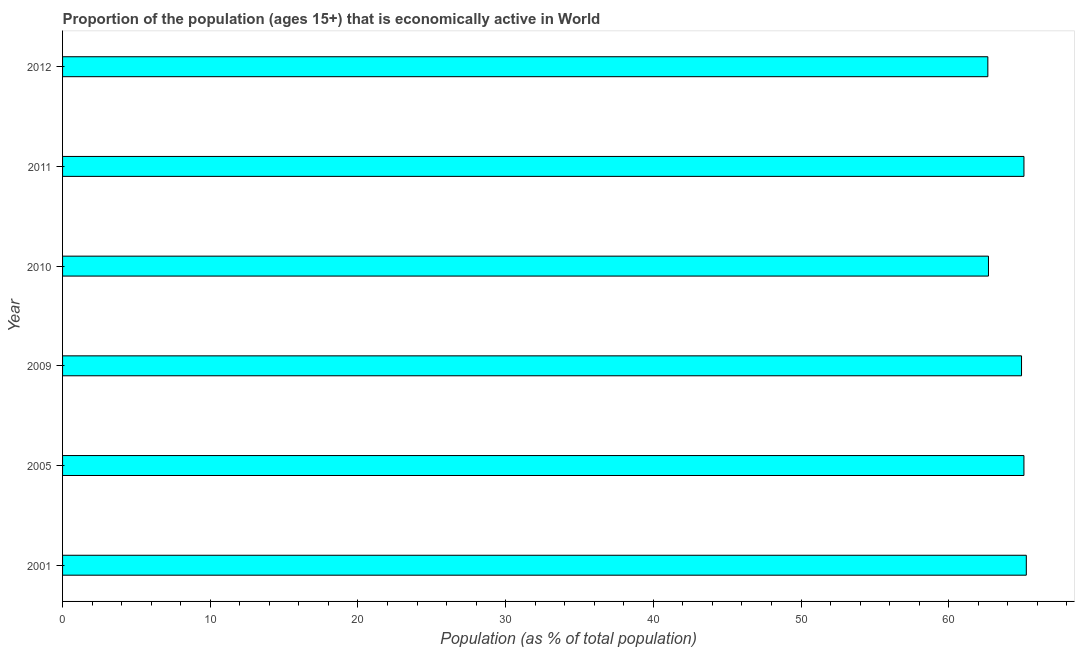Does the graph contain any zero values?
Offer a terse response. No. What is the title of the graph?
Give a very brief answer. Proportion of the population (ages 15+) that is economically active in World. What is the label or title of the X-axis?
Ensure brevity in your answer.  Population (as % of total population). What is the label or title of the Y-axis?
Ensure brevity in your answer.  Year. What is the percentage of economically active population in 2010?
Give a very brief answer. 62.69. Across all years, what is the maximum percentage of economically active population?
Your response must be concise. 65.26. Across all years, what is the minimum percentage of economically active population?
Ensure brevity in your answer.  62.65. What is the sum of the percentage of economically active population?
Provide a succinct answer. 385.73. What is the difference between the percentage of economically active population in 2001 and 2009?
Provide a short and direct response. 0.32. What is the average percentage of economically active population per year?
Make the answer very short. 64.29. What is the median percentage of economically active population?
Offer a terse response. 65.01. In how many years, is the percentage of economically active population greater than 10 %?
Offer a very short reply. 6. Is the difference between the percentage of economically active population in 2001 and 2012 greater than the difference between any two years?
Your answer should be very brief. Yes. What is the difference between the highest and the second highest percentage of economically active population?
Keep it short and to the point. 0.16. Is the sum of the percentage of economically active population in 2001 and 2011 greater than the maximum percentage of economically active population across all years?
Ensure brevity in your answer.  Yes. What is the difference between the highest and the lowest percentage of economically active population?
Offer a very short reply. 2.6. How many years are there in the graph?
Make the answer very short. 6. What is the difference between two consecutive major ticks on the X-axis?
Your response must be concise. 10. Are the values on the major ticks of X-axis written in scientific E-notation?
Provide a short and direct response. No. What is the Population (as % of total population) of 2001?
Your answer should be very brief. 65.26. What is the Population (as % of total population) in 2005?
Provide a succinct answer. 65.1. What is the Population (as % of total population) of 2009?
Keep it short and to the point. 64.93. What is the Population (as % of total population) in 2010?
Your answer should be compact. 62.69. What is the Population (as % of total population) of 2011?
Your response must be concise. 65.1. What is the Population (as % of total population) of 2012?
Offer a terse response. 62.65. What is the difference between the Population (as % of total population) in 2001 and 2005?
Provide a succinct answer. 0.16. What is the difference between the Population (as % of total population) in 2001 and 2009?
Ensure brevity in your answer.  0.32. What is the difference between the Population (as % of total population) in 2001 and 2010?
Your answer should be very brief. 2.56. What is the difference between the Population (as % of total population) in 2001 and 2011?
Give a very brief answer. 0.16. What is the difference between the Population (as % of total population) in 2001 and 2012?
Offer a very short reply. 2.6. What is the difference between the Population (as % of total population) in 2005 and 2009?
Give a very brief answer. 0.16. What is the difference between the Population (as % of total population) in 2005 and 2010?
Offer a terse response. 2.4. What is the difference between the Population (as % of total population) in 2005 and 2011?
Your answer should be compact. -0. What is the difference between the Population (as % of total population) in 2005 and 2012?
Give a very brief answer. 2.44. What is the difference between the Population (as % of total population) in 2009 and 2010?
Keep it short and to the point. 2.24. What is the difference between the Population (as % of total population) in 2009 and 2011?
Offer a terse response. -0.16. What is the difference between the Population (as % of total population) in 2009 and 2012?
Provide a short and direct response. 2.28. What is the difference between the Population (as % of total population) in 2010 and 2011?
Keep it short and to the point. -2.4. What is the difference between the Population (as % of total population) in 2010 and 2012?
Keep it short and to the point. 0.04. What is the difference between the Population (as % of total population) in 2011 and 2012?
Ensure brevity in your answer.  2.45. What is the ratio of the Population (as % of total population) in 2001 to that in 2005?
Your answer should be very brief. 1. What is the ratio of the Population (as % of total population) in 2001 to that in 2010?
Your response must be concise. 1.04. What is the ratio of the Population (as % of total population) in 2001 to that in 2012?
Your response must be concise. 1.04. What is the ratio of the Population (as % of total population) in 2005 to that in 2009?
Keep it short and to the point. 1. What is the ratio of the Population (as % of total population) in 2005 to that in 2010?
Make the answer very short. 1.04. What is the ratio of the Population (as % of total population) in 2005 to that in 2012?
Offer a very short reply. 1.04. What is the ratio of the Population (as % of total population) in 2009 to that in 2010?
Your response must be concise. 1.04. What is the ratio of the Population (as % of total population) in 2009 to that in 2012?
Give a very brief answer. 1.04. What is the ratio of the Population (as % of total population) in 2010 to that in 2012?
Ensure brevity in your answer.  1. What is the ratio of the Population (as % of total population) in 2011 to that in 2012?
Your answer should be compact. 1.04. 